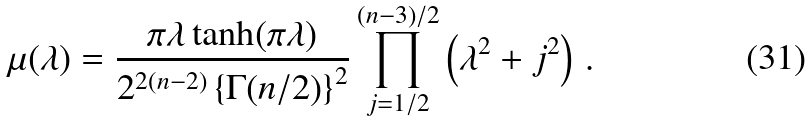Convert formula to latex. <formula><loc_0><loc_0><loc_500><loc_500>\mu ( \lambda ) = \frac { \pi \lambda \tanh ( \pi \lambda ) } { 2 ^ { 2 ( n - 2 ) } \left \{ \Gamma ( n / 2 ) \right \} ^ { 2 } } \prod ^ { ( n - 3 ) / 2 } _ { j = 1 / 2 } \left ( \lambda ^ { 2 } + j ^ { 2 } \right ) \, .</formula> 